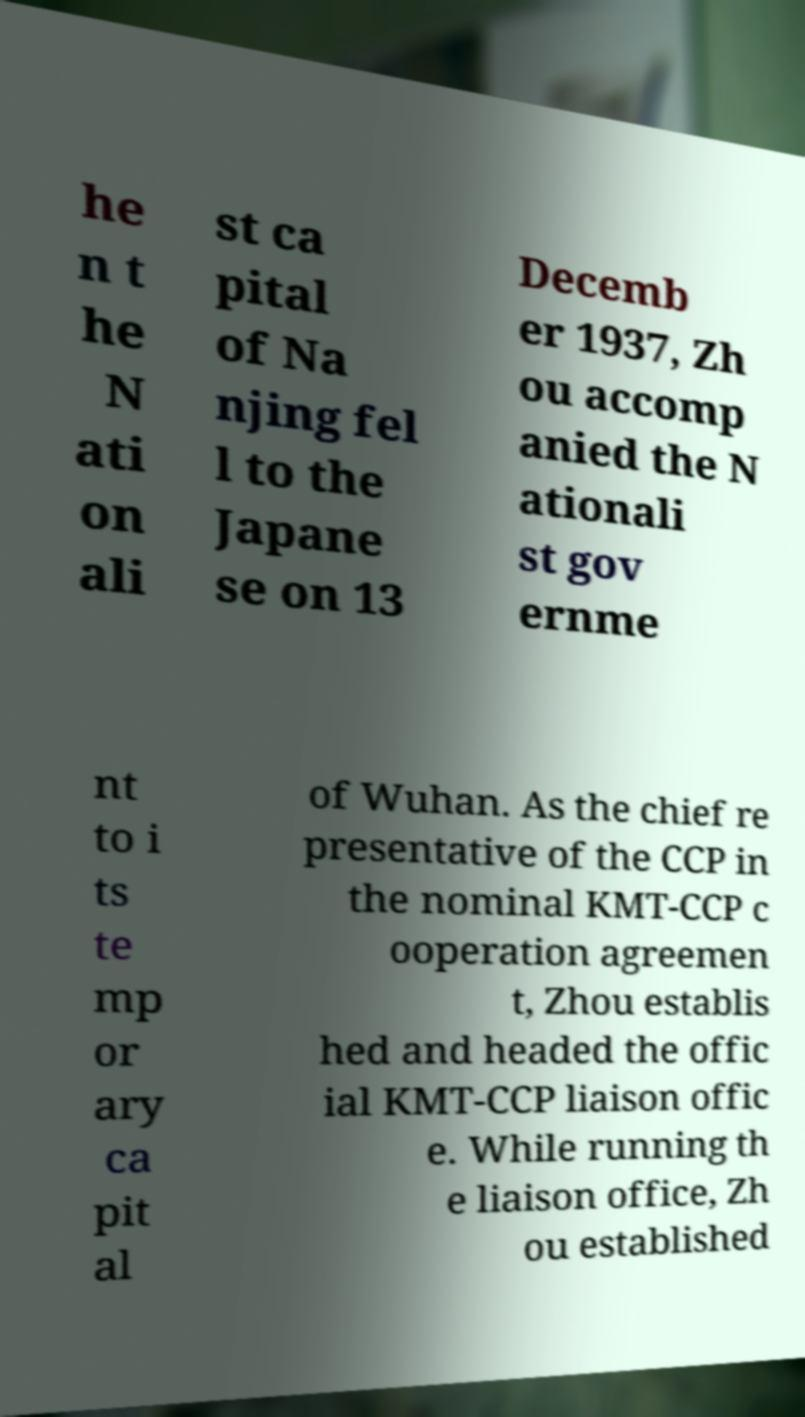For documentation purposes, I need the text within this image transcribed. Could you provide that? he n t he N ati on ali st ca pital of Na njing fel l to the Japane se on 13 Decemb er 1937, Zh ou accomp anied the N ationali st gov ernme nt to i ts te mp or ary ca pit al of Wuhan. As the chief re presentative of the CCP in the nominal KMT-CCP c ooperation agreemen t, Zhou establis hed and headed the offic ial KMT-CCP liaison offic e. While running th e liaison office, Zh ou established 